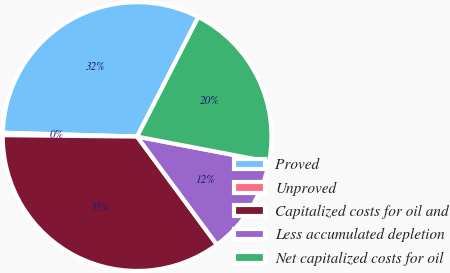Convert chart. <chart><loc_0><loc_0><loc_500><loc_500><pie_chart><fcel>Proved<fcel>Unproved<fcel>Capitalized costs for oil and<fcel>Less accumulated depletion<fcel>Net capitalized costs for oil<nl><fcel>32.08%<fcel>0.28%<fcel>35.29%<fcel>11.88%<fcel>20.47%<nl></chart> 